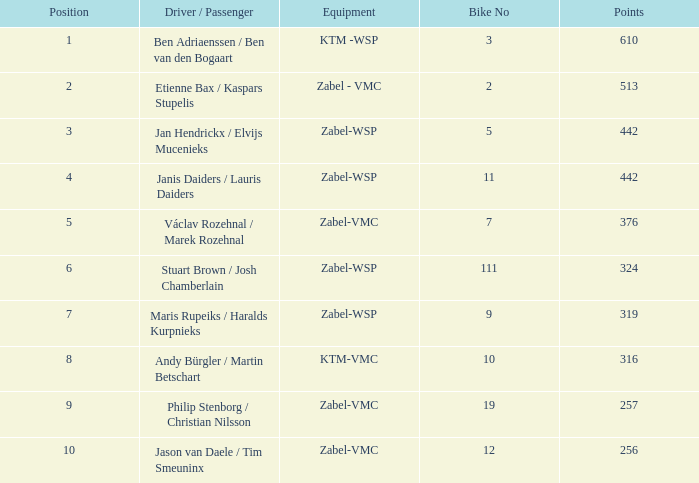What is the apparatus with a score less than 442 and a ranking of 9? Zabel-VMC. 